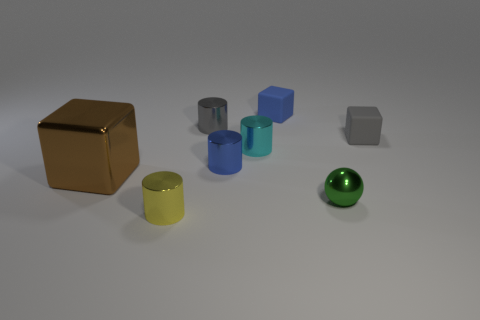Is there any other thing that has the same material as the small yellow cylinder?
Provide a succinct answer. Yes. How many cyan cylinders have the same material as the large brown thing?
Your answer should be compact. 1. Are there the same number of tiny green metal spheres that are on the right side of the tiny green ball and yellow metallic things?
Make the answer very short. No. What size is the shiny cylinder that is in front of the large cube?
Your answer should be very brief. Small. How many small objects are either yellow things or rubber blocks?
Make the answer very short. 3. The large shiny object that is the same shape as the small gray matte thing is what color?
Keep it short and to the point. Brown. Is the size of the brown metallic block the same as the gray shiny thing?
Give a very brief answer. No. How many objects are tiny yellow metal cylinders or tiny metallic cylinders behind the blue cylinder?
Make the answer very short. 3. There is a metallic cylinder in front of the metallic thing left of the yellow metal cylinder; what color is it?
Offer a very short reply. Yellow. There is a block that is in front of the gray matte thing; does it have the same color as the small sphere?
Your response must be concise. No. 